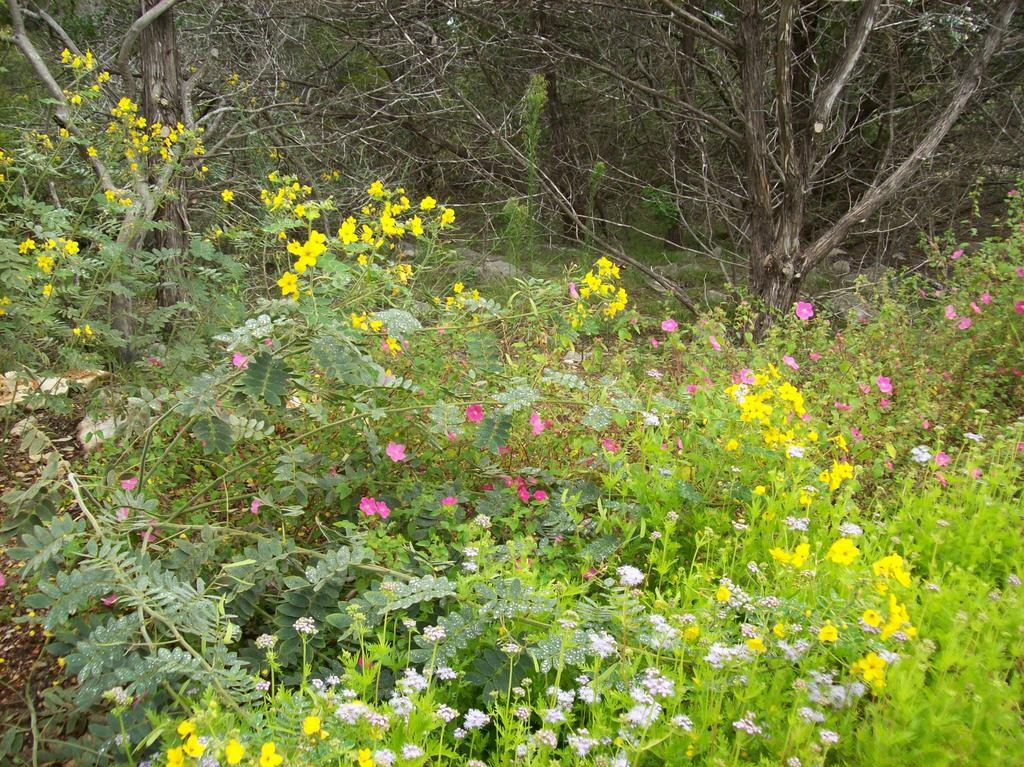What type of living organisms can be seen in the image? There are plants in the image. What is the color of the plants in the image? The plants are green in color. What additional features can be observed on the plants? There are flowers on the plants. What colors are the flowers? The flowers are purple, yellow, and pink in color. What can be seen in the background of the image? There are trees in the background of the image. Can you see a shoe hanging from one of the trees in the image? There is no shoe present in the image; it only features plants, flowers, and trees. 